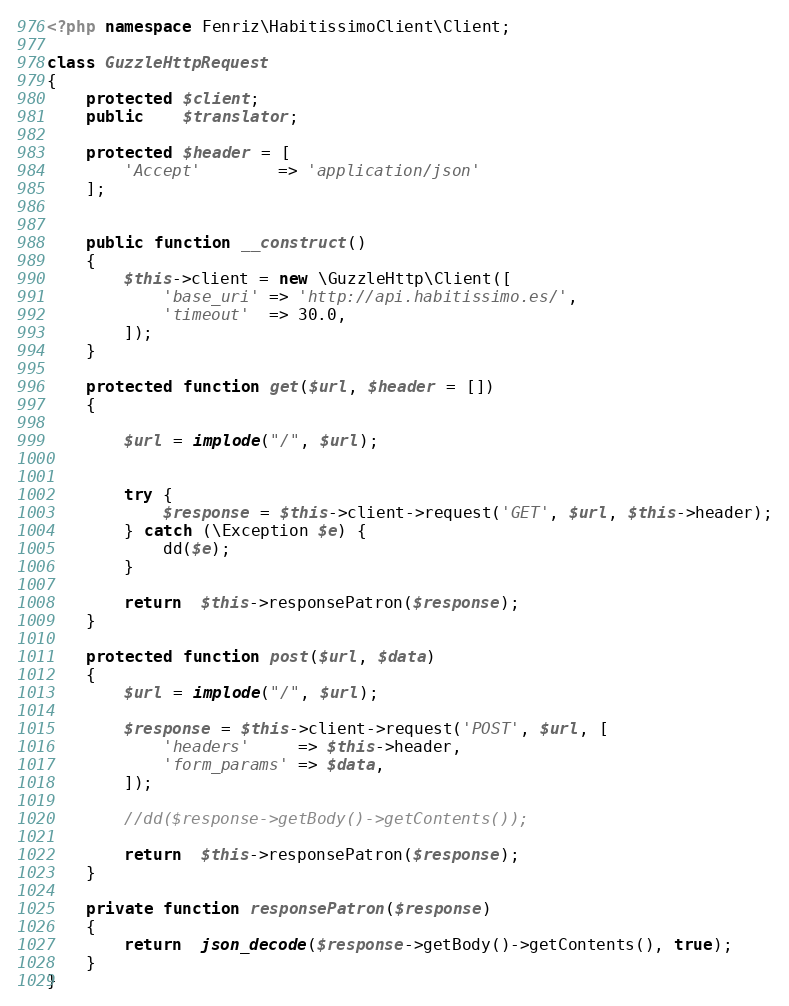Convert code to text. <code><loc_0><loc_0><loc_500><loc_500><_PHP_><?php namespace Fenriz\HabitissimoClient\Client;

class GuzzleHttpRequest
{
    protected $client;
    public    $translator;

    protected $header = [
        'Accept'        => 'application/json'
    ];


    public function __construct()
    {
        $this->client = new \GuzzleHttp\Client([
            'base_uri' => 'http://api.habitissimo.es/',
            'timeout'  => 30.0,
        ]);
    }

    protected function get($url, $header = [])
    {

        $url = implode("/", $url);


        try {
            $response = $this->client->request('GET', $url, $this->header);
        } catch (\Exception $e) {
            dd($e);
        }

        return  $this->responsePatron($response);
    }

    protected function post($url, $data)
    {
        $url = implode("/", $url);

        $response = $this->client->request('POST', $url, [
            'headers'     => $this->header,
            'form_params' => $data,
        ]);

        //dd($response->getBody()->getContents());

        return  $this->responsePatron($response);
    }

    private function responsePatron($response)
    {
        return  json_decode($response->getBody()->getContents(), true);
    }
}
</code> 